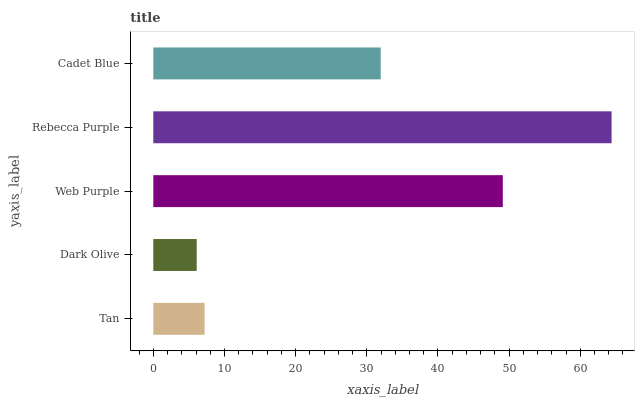Is Dark Olive the minimum?
Answer yes or no. Yes. Is Rebecca Purple the maximum?
Answer yes or no. Yes. Is Web Purple the minimum?
Answer yes or no. No. Is Web Purple the maximum?
Answer yes or no. No. Is Web Purple greater than Dark Olive?
Answer yes or no. Yes. Is Dark Olive less than Web Purple?
Answer yes or no. Yes. Is Dark Olive greater than Web Purple?
Answer yes or no. No. Is Web Purple less than Dark Olive?
Answer yes or no. No. Is Cadet Blue the high median?
Answer yes or no. Yes. Is Cadet Blue the low median?
Answer yes or no. Yes. Is Tan the high median?
Answer yes or no. No. Is Web Purple the low median?
Answer yes or no. No. 